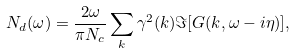Convert formula to latex. <formula><loc_0><loc_0><loc_500><loc_500>N _ { d } ( \omega ) = \frac { 2 \omega } { \pi N _ { c } } \sum _ { k } \gamma ^ { 2 } ( { k } ) \Im [ G ( { k } , \omega - i \eta ) ] ,</formula> 